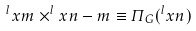Convert formula to latex. <formula><loc_0><loc_0><loc_500><loc_500>^ { l } x { m } \times ^ { l } x { n - m } \equiv \varPi _ { G } ( ^ { l } x { n } )</formula> 